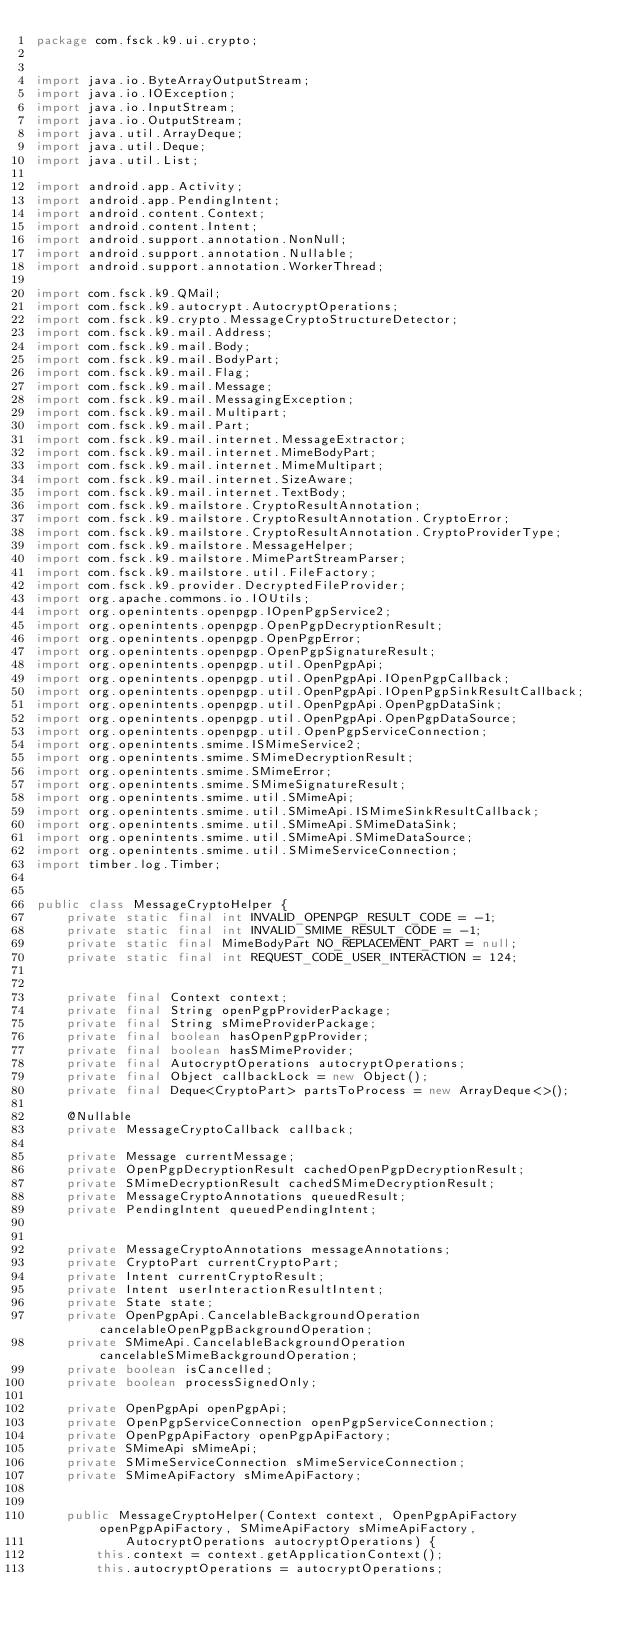Convert code to text. <code><loc_0><loc_0><loc_500><loc_500><_Java_>package com.fsck.k9.ui.crypto;


import java.io.ByteArrayOutputStream;
import java.io.IOException;
import java.io.InputStream;
import java.io.OutputStream;
import java.util.ArrayDeque;
import java.util.Deque;
import java.util.List;

import android.app.Activity;
import android.app.PendingIntent;
import android.content.Context;
import android.content.Intent;
import android.support.annotation.NonNull;
import android.support.annotation.Nullable;
import android.support.annotation.WorkerThread;

import com.fsck.k9.QMail;
import com.fsck.k9.autocrypt.AutocryptOperations;
import com.fsck.k9.crypto.MessageCryptoStructureDetector;
import com.fsck.k9.mail.Address;
import com.fsck.k9.mail.Body;
import com.fsck.k9.mail.BodyPart;
import com.fsck.k9.mail.Flag;
import com.fsck.k9.mail.Message;
import com.fsck.k9.mail.MessagingException;
import com.fsck.k9.mail.Multipart;
import com.fsck.k9.mail.Part;
import com.fsck.k9.mail.internet.MessageExtractor;
import com.fsck.k9.mail.internet.MimeBodyPart;
import com.fsck.k9.mail.internet.MimeMultipart;
import com.fsck.k9.mail.internet.SizeAware;
import com.fsck.k9.mail.internet.TextBody;
import com.fsck.k9.mailstore.CryptoResultAnnotation;
import com.fsck.k9.mailstore.CryptoResultAnnotation.CryptoError;
import com.fsck.k9.mailstore.CryptoResultAnnotation.CryptoProviderType;
import com.fsck.k9.mailstore.MessageHelper;
import com.fsck.k9.mailstore.MimePartStreamParser;
import com.fsck.k9.mailstore.util.FileFactory;
import com.fsck.k9.provider.DecryptedFileProvider;
import org.apache.commons.io.IOUtils;
import org.openintents.openpgp.IOpenPgpService2;
import org.openintents.openpgp.OpenPgpDecryptionResult;
import org.openintents.openpgp.OpenPgpError;
import org.openintents.openpgp.OpenPgpSignatureResult;
import org.openintents.openpgp.util.OpenPgpApi;
import org.openintents.openpgp.util.OpenPgpApi.IOpenPgpCallback;
import org.openintents.openpgp.util.OpenPgpApi.IOpenPgpSinkResultCallback;
import org.openintents.openpgp.util.OpenPgpApi.OpenPgpDataSink;
import org.openintents.openpgp.util.OpenPgpApi.OpenPgpDataSource;
import org.openintents.openpgp.util.OpenPgpServiceConnection;
import org.openintents.smime.ISMimeService2;
import org.openintents.smime.SMimeDecryptionResult;
import org.openintents.smime.SMimeError;
import org.openintents.smime.SMimeSignatureResult;
import org.openintents.smime.util.SMimeApi;
import org.openintents.smime.util.SMimeApi.ISMimeSinkResultCallback;
import org.openintents.smime.util.SMimeApi.SMimeDataSink;
import org.openintents.smime.util.SMimeApi.SMimeDataSource;
import org.openintents.smime.util.SMimeServiceConnection;
import timber.log.Timber;


public class MessageCryptoHelper {
    private static final int INVALID_OPENPGP_RESULT_CODE = -1;
    private static final int INVALID_SMIME_RESULT_CODE = -1;
    private static final MimeBodyPart NO_REPLACEMENT_PART = null;
    private static final int REQUEST_CODE_USER_INTERACTION = 124;


    private final Context context;
    private final String openPgpProviderPackage;
    private final String sMimeProviderPackage;
    private final boolean hasOpenPgpProvider;
    private final boolean hasSMimeProvider;
    private final AutocryptOperations autocryptOperations;
    private final Object callbackLock = new Object();
    private final Deque<CryptoPart> partsToProcess = new ArrayDeque<>();

    @Nullable
    private MessageCryptoCallback callback;

    private Message currentMessage;
    private OpenPgpDecryptionResult cachedOpenPgpDecryptionResult;
    private SMimeDecryptionResult cachedSMimeDecryptionResult;
    private MessageCryptoAnnotations queuedResult;
    private PendingIntent queuedPendingIntent;


    private MessageCryptoAnnotations messageAnnotations;
    private CryptoPart currentCryptoPart;
    private Intent currentCryptoResult;
    private Intent userInteractionResultIntent;
    private State state;
    private OpenPgpApi.CancelableBackgroundOperation cancelableOpenPgpBackgroundOperation;
    private SMimeApi.CancelableBackgroundOperation cancelableSMimeBackgroundOperation;
    private boolean isCancelled;
    private boolean processSignedOnly;

    private OpenPgpApi openPgpApi;
    private OpenPgpServiceConnection openPgpServiceConnection;
    private OpenPgpApiFactory openPgpApiFactory;
    private SMimeApi sMimeApi;
    private SMimeServiceConnection sMimeServiceConnection;
    private SMimeApiFactory sMimeApiFactory;


    public MessageCryptoHelper(Context context, OpenPgpApiFactory openPgpApiFactory, SMimeApiFactory sMimeApiFactory,
            AutocryptOperations autocryptOperations) {
        this.context = context.getApplicationContext();
        this.autocryptOperations = autocryptOperations;</code> 